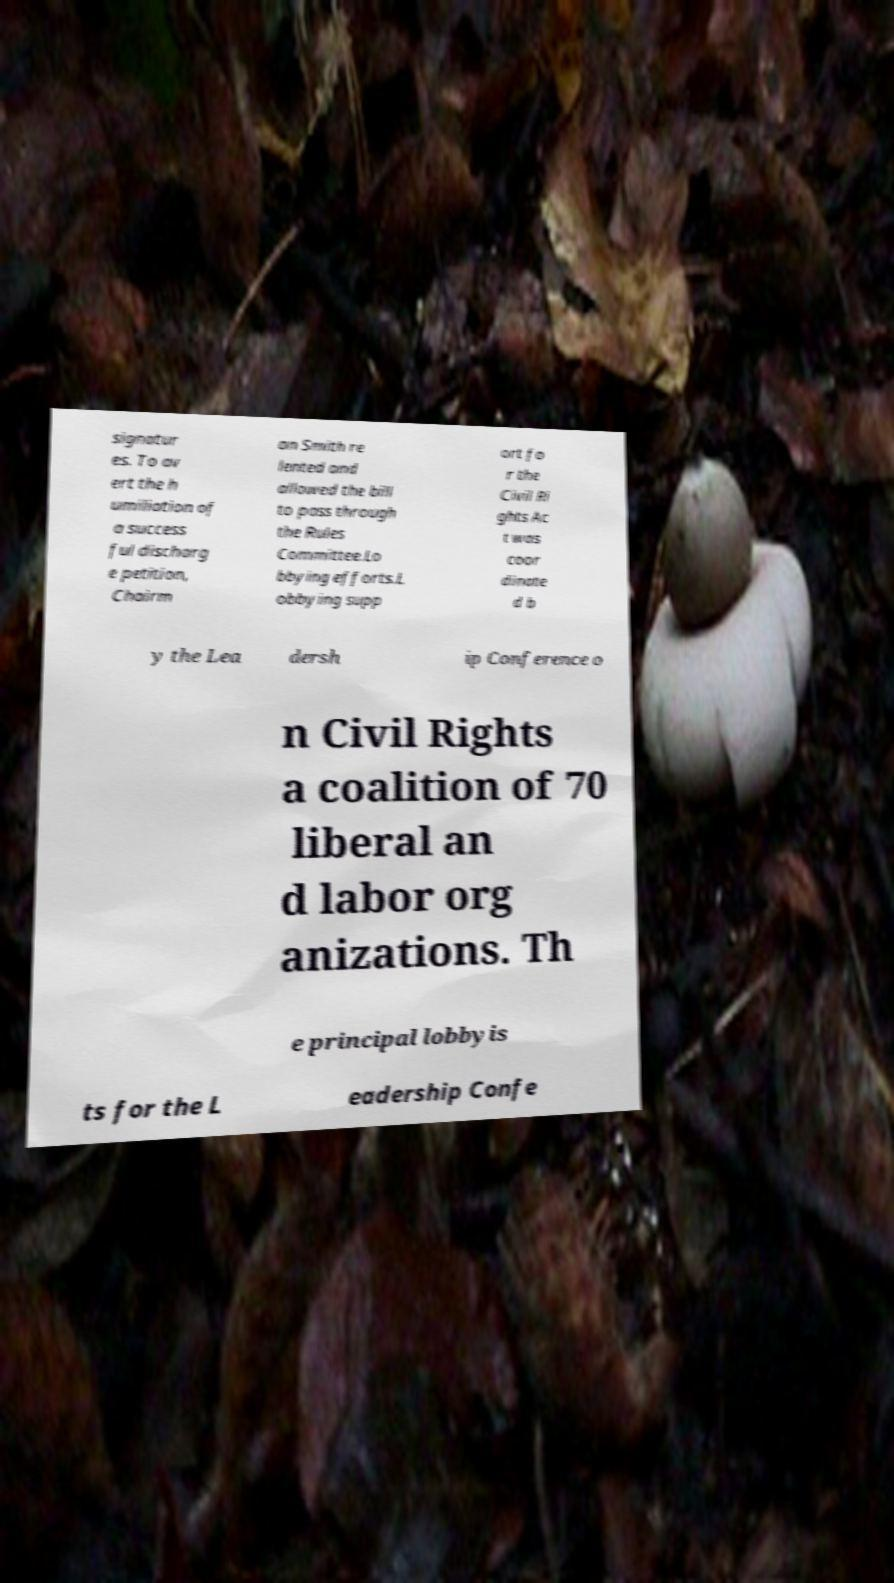Could you assist in decoding the text presented in this image and type it out clearly? signatur es. To av ert the h umiliation of a success ful discharg e petition, Chairm an Smith re lented and allowed the bill to pass through the Rules Committee.Lo bbying efforts.L obbying supp ort fo r the Civil Ri ghts Ac t was coor dinate d b y the Lea dersh ip Conference o n Civil Rights a coalition of 70 liberal an d labor org anizations. Th e principal lobbyis ts for the L eadership Confe 